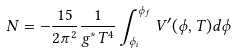Convert formula to latex. <formula><loc_0><loc_0><loc_500><loc_500>N = - \frac { 1 5 } { 2 \pi ^ { 2 } } \frac { 1 } { g ^ { * } T ^ { 4 } } \int _ { \phi _ { i } } ^ { \phi _ { f } } V ^ { \prime } ( \phi , T ) d \phi</formula> 